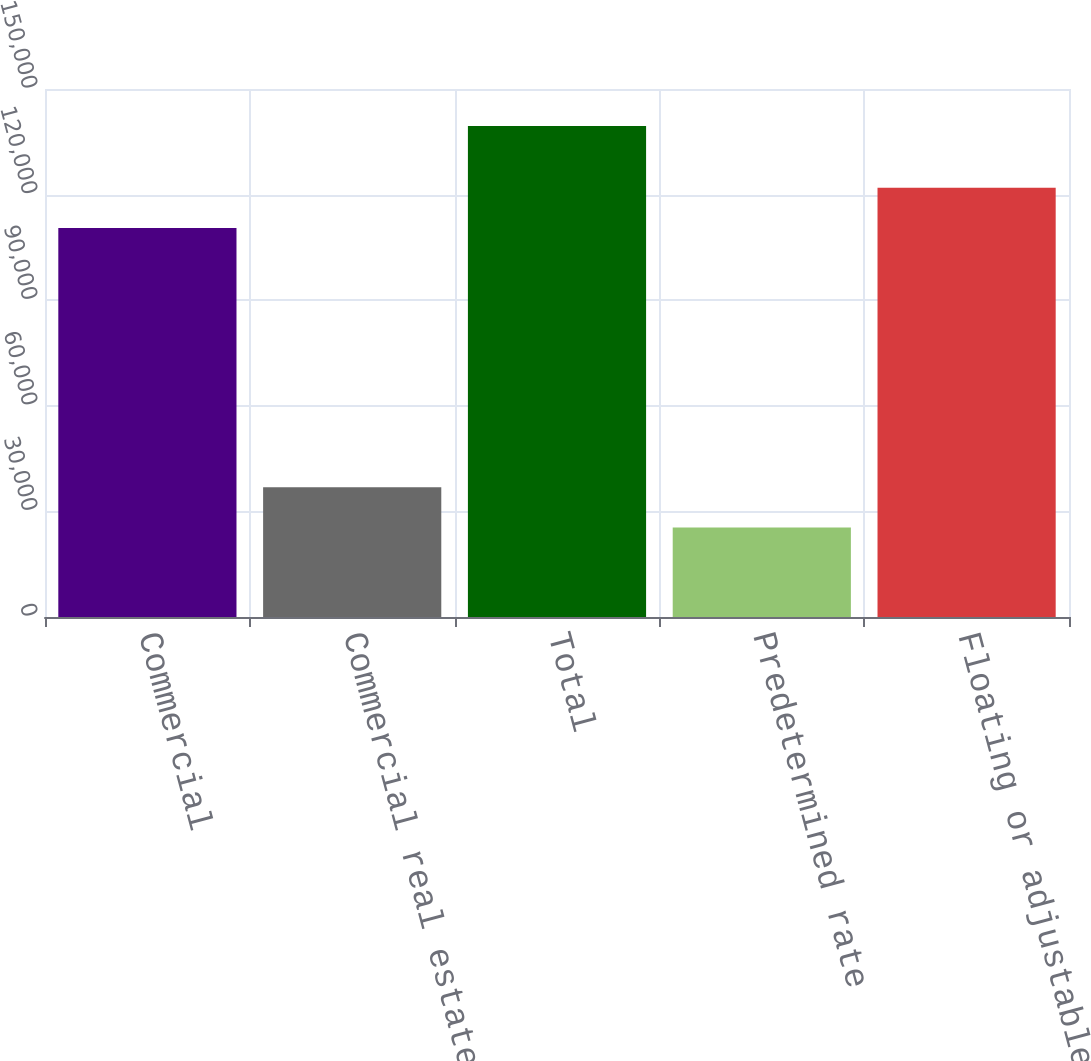Convert chart to OTSL. <chart><loc_0><loc_0><loc_500><loc_500><bar_chart><fcel>Commercial<fcel>Commercial real estate<fcel>Total<fcel>Predetermined rate<fcel>Floating or adjustable rate<nl><fcel>110527<fcel>36851<fcel>139505<fcel>25445<fcel>121933<nl></chart> 